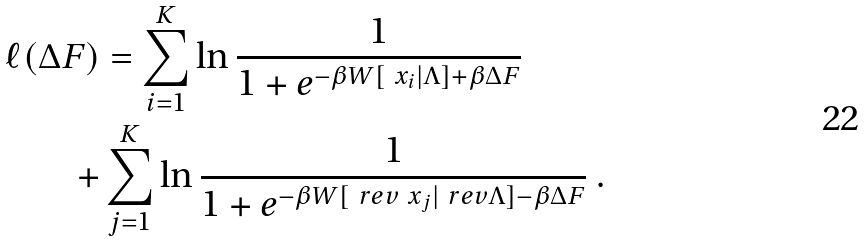<formula> <loc_0><loc_0><loc_500><loc_500>\ell ( \Delta F ) & = \sum _ { i = 1 } ^ { K } \ln \frac { 1 } { 1 + e ^ { - \beta W [ \ x _ { i } | \Lambda ] + \beta \Delta F } } \\ + & \sum _ { j = 1 } ^ { K } \ln \frac { 1 } { 1 + e ^ { - \beta W [ \ r e v { \ x } _ { j } | \ r e v { \Lambda } ] - \beta \Delta F } } \ .</formula> 